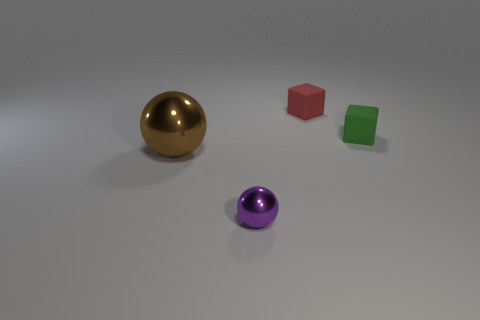There is a matte object that is right of the red rubber object; is it the same shape as the small thing to the left of the small red thing?
Provide a succinct answer. No. The object left of the object in front of the metal thing that is left of the tiny purple shiny ball is what color?
Offer a terse response. Brown. There is a object to the left of the small purple object; what color is it?
Your answer should be very brief. Brown. What is the color of the metal sphere that is the same size as the green matte cube?
Your response must be concise. Purple. Do the red cube and the purple ball have the same size?
Your answer should be compact. Yes. What number of green matte cubes are in front of the green matte object?
Your answer should be compact. 0. What number of things are either small things that are to the right of the purple metal thing or tiny gray rubber cylinders?
Offer a very short reply. 2. Is the number of small green objects left of the green matte cube greater than the number of matte blocks in front of the purple object?
Make the answer very short. No. There is a purple thing; does it have the same size as the object left of the purple shiny sphere?
Ensure brevity in your answer.  No. What number of blocks are either purple things or yellow metal things?
Keep it short and to the point. 0. 